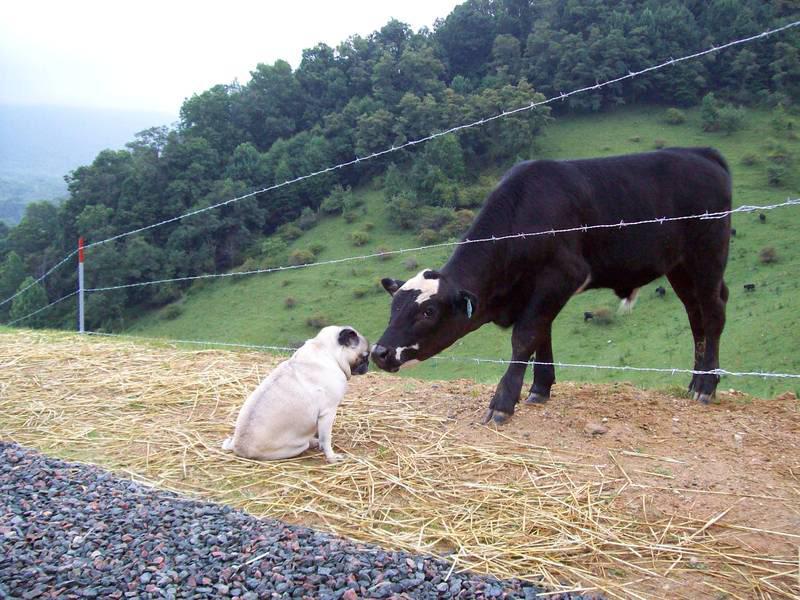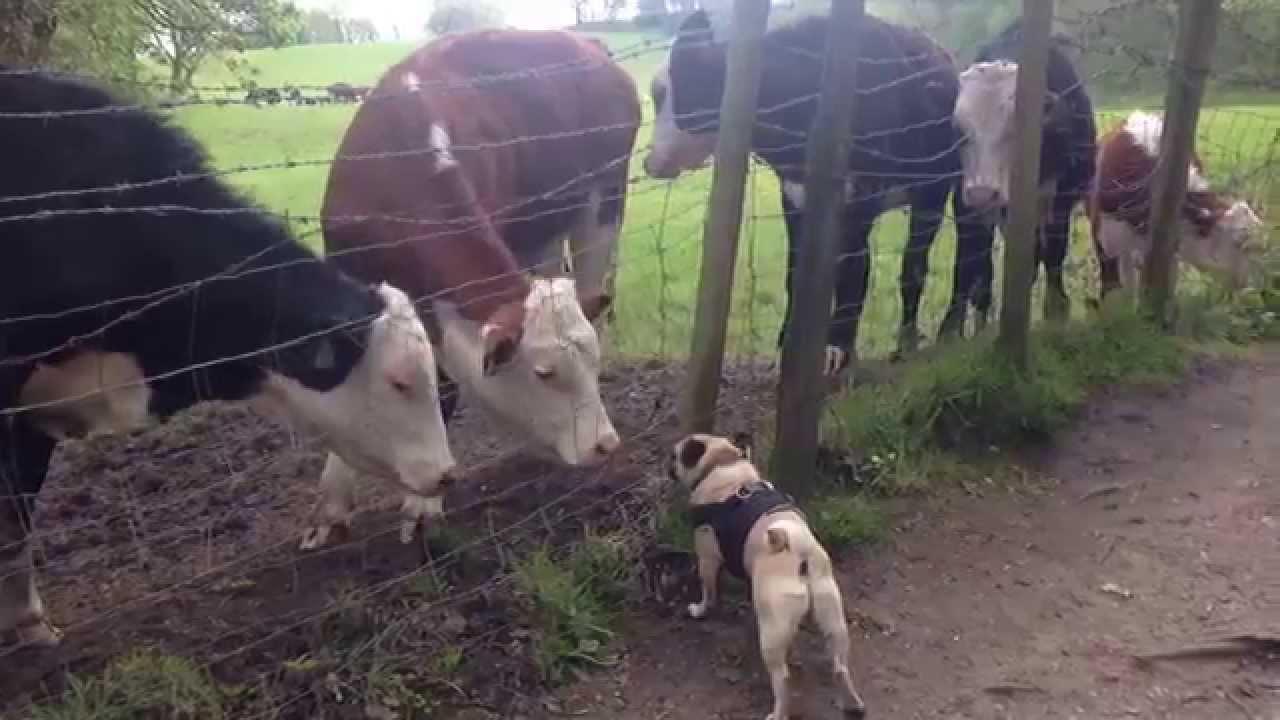The first image is the image on the left, the second image is the image on the right. Considering the images on both sides, is "Images show a total of two pugs dressed in black and white cow costumes." valid? Answer yes or no. No. 